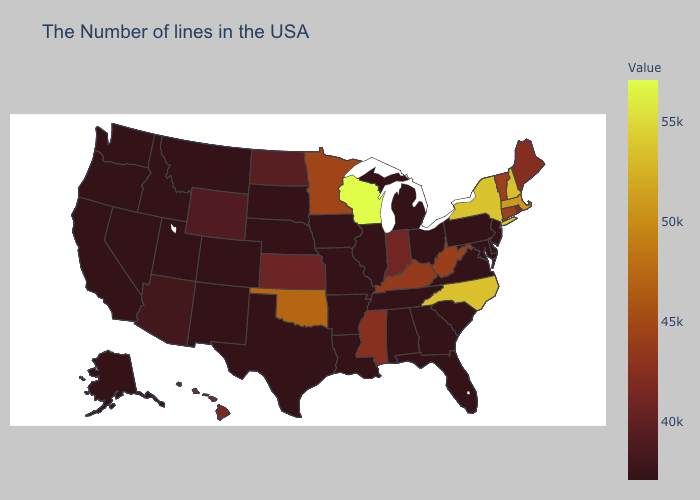Which states have the highest value in the USA?
Short answer required. Wisconsin. Does West Virginia have the lowest value in the South?
Short answer required. No. Which states hav the highest value in the West?
Concise answer only. Hawaii. Is the legend a continuous bar?
Keep it brief. Yes. Does New York have the highest value in the Northeast?
Be succinct. Yes. 